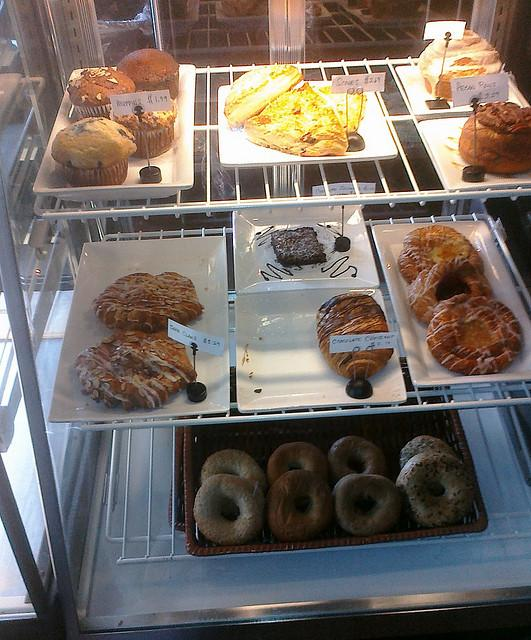What type of Danish is in the middle of the other two? chocolate 